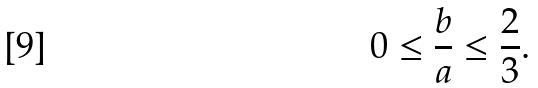Convert formula to latex. <formula><loc_0><loc_0><loc_500><loc_500>0 \leq \frac { b } { a } \leq \frac { 2 } { 3 } .</formula> 